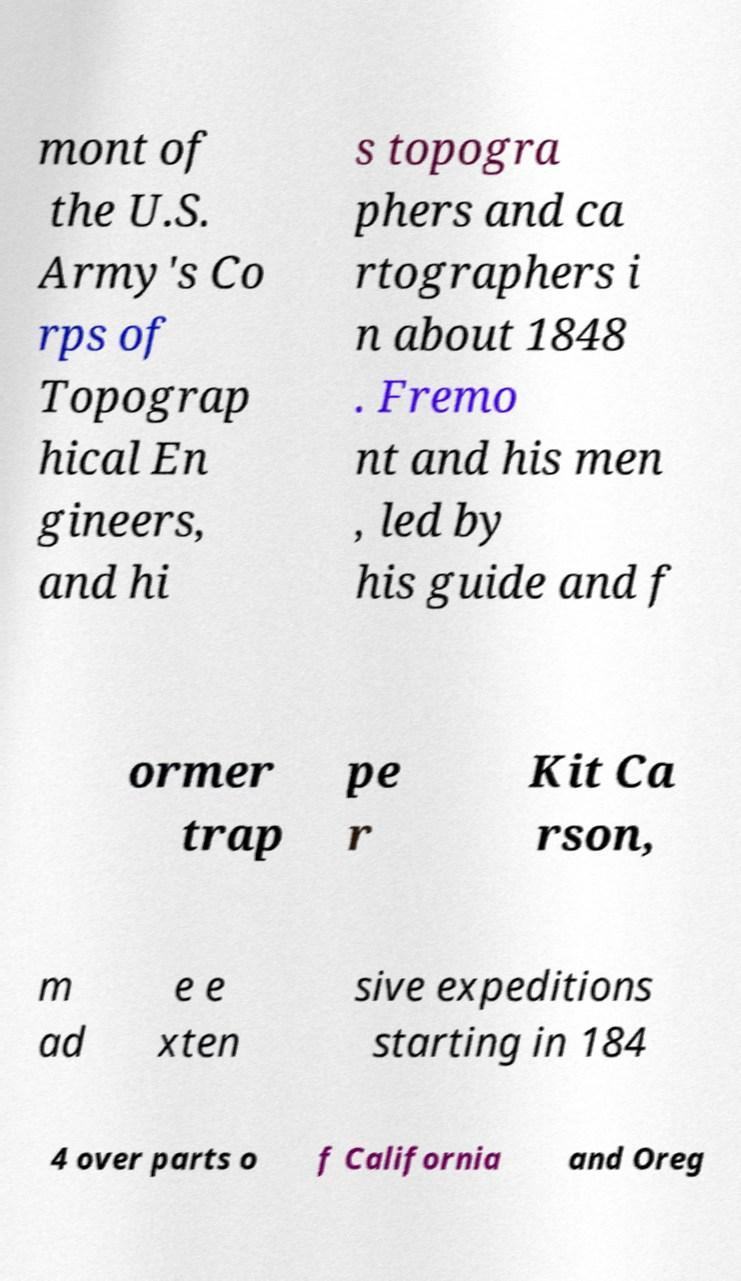Please read and relay the text visible in this image. What does it say? mont of the U.S. Army's Co rps of Topograp hical En gineers, and hi s topogra phers and ca rtographers i n about 1848 . Fremo nt and his men , led by his guide and f ormer trap pe r Kit Ca rson, m ad e e xten sive expeditions starting in 184 4 over parts o f California and Oreg 